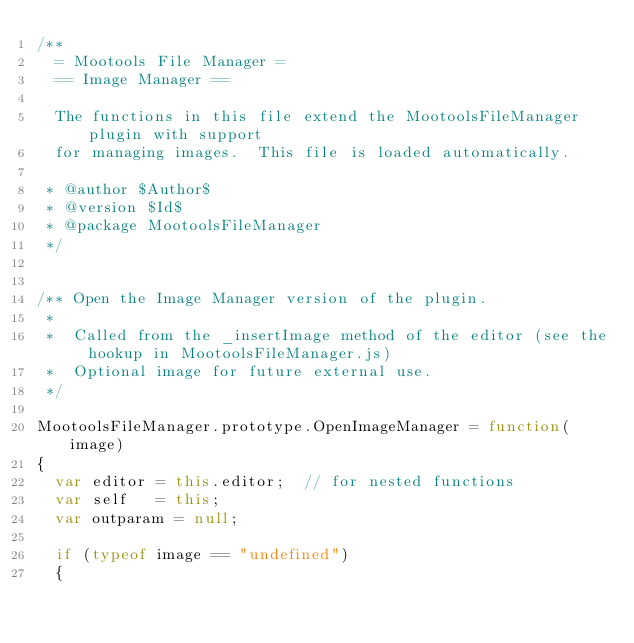Convert code to text. <code><loc_0><loc_0><loc_500><loc_500><_JavaScript_>/**
  = Mootools File Manager =
  == Image Manager ==
  
  The functions in this file extend the MootoolsFileManager plugin with support
  for managing images.  This file is loaded automatically.
     
 * @author $Author$
 * @version $Id$
 * @package MootoolsFileManager
 */


/** Open the Image Manager version of the plugin.
 *
 *  Called from the _insertImage method of the editor (see the hookup in MootoolsFileManager.js)
 *  Optional image for future external use.
 */
 
MootoolsFileManager.prototype.OpenImageManager = function(image)
{
  var editor = this.editor;  // for nested functions
  var self   = this;
  var outparam = null;
  
  if (typeof image == "undefined") 
  {</code> 